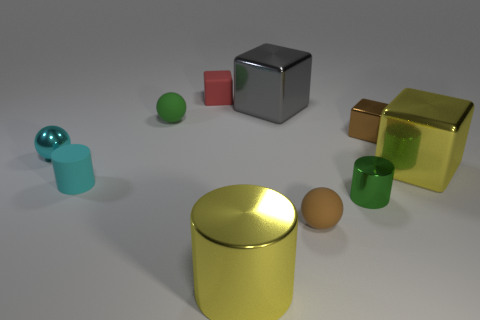How many other things are there of the same color as the tiny matte cylinder?
Offer a very short reply. 1. What number of cylinders are either gray metal objects or tiny green metallic things?
Make the answer very short. 1. There is a large metallic thing on the left side of the large object behind the brown metal block; what color is it?
Keep it short and to the point. Yellow. There is a green metal object; what shape is it?
Make the answer very short. Cylinder. There is a yellow metallic thing right of the green metallic cylinder; is its size the same as the cyan rubber cylinder?
Make the answer very short. No. Are there any gray things that have the same material as the yellow block?
Offer a very short reply. Yes. How many objects are either tiny cubes that are behind the small green rubber object or small gray things?
Make the answer very short. 1. Are any big blue spheres visible?
Your answer should be compact. No. What is the shape of the large shiny object that is both left of the tiny brown rubber thing and right of the yellow metal cylinder?
Give a very brief answer. Cube. How big is the yellow object that is behind the tiny green shiny object?
Your answer should be compact. Large. 